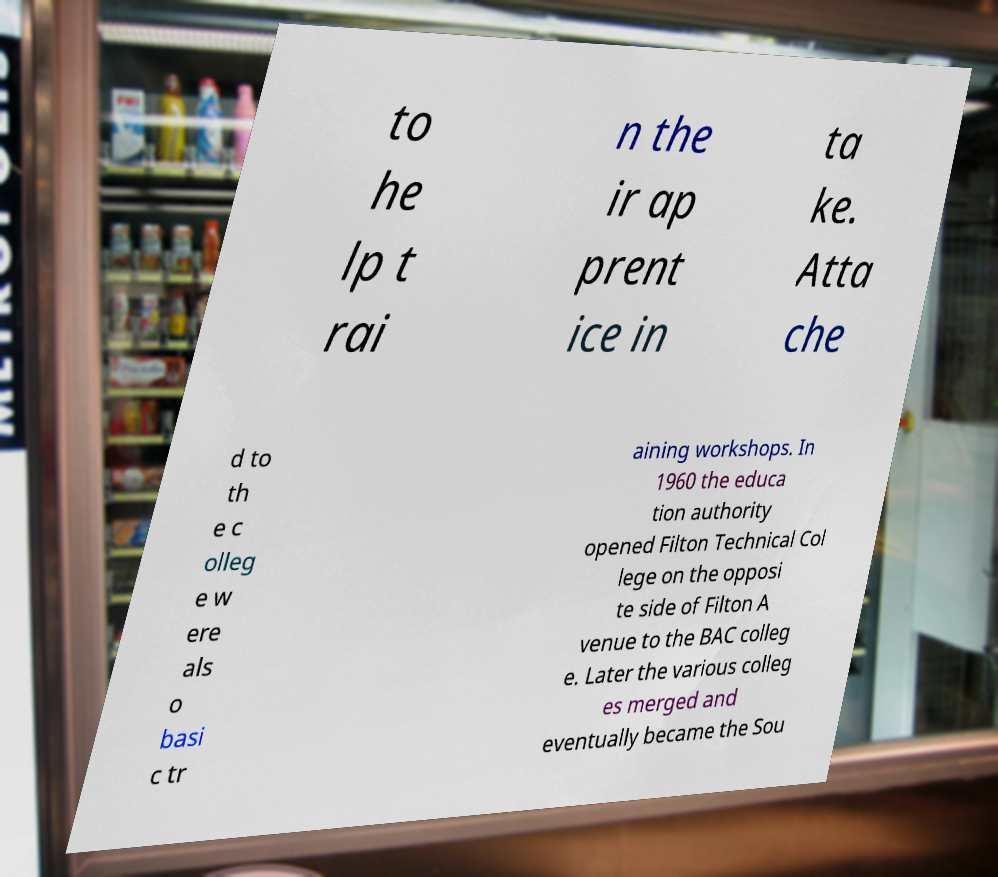There's text embedded in this image that I need extracted. Can you transcribe it verbatim? to he lp t rai n the ir ap prent ice in ta ke. Atta che d to th e c olleg e w ere als o basi c tr aining workshops. In 1960 the educa tion authority opened Filton Technical Col lege on the opposi te side of Filton A venue to the BAC colleg e. Later the various colleg es merged and eventually became the Sou 